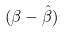Convert formula to latex. <formula><loc_0><loc_0><loc_500><loc_500>( \beta - \hat { \beta } )</formula> 